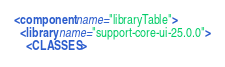<code> <loc_0><loc_0><loc_500><loc_500><_XML_><component name="libraryTable">
  <library name="support-core-ui-25.0.0">
    <CLASSES></code> 